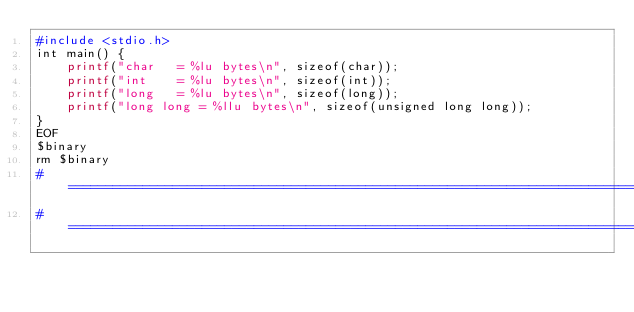<code> <loc_0><loc_0><loc_500><loc_500><_Bash_>#include <stdio.h>
int main() {
    printf("char   = %lu bytes\n", sizeof(char));
    printf("int    = %lu bytes\n", sizeof(int));
    printf("long   = %lu bytes\n", sizeof(long));
    printf("long long = %llu bytes\n", sizeof(unsigned long long));
}
EOF
$binary
rm $binary
#===============================================================================
#===============================================================================
</code> 